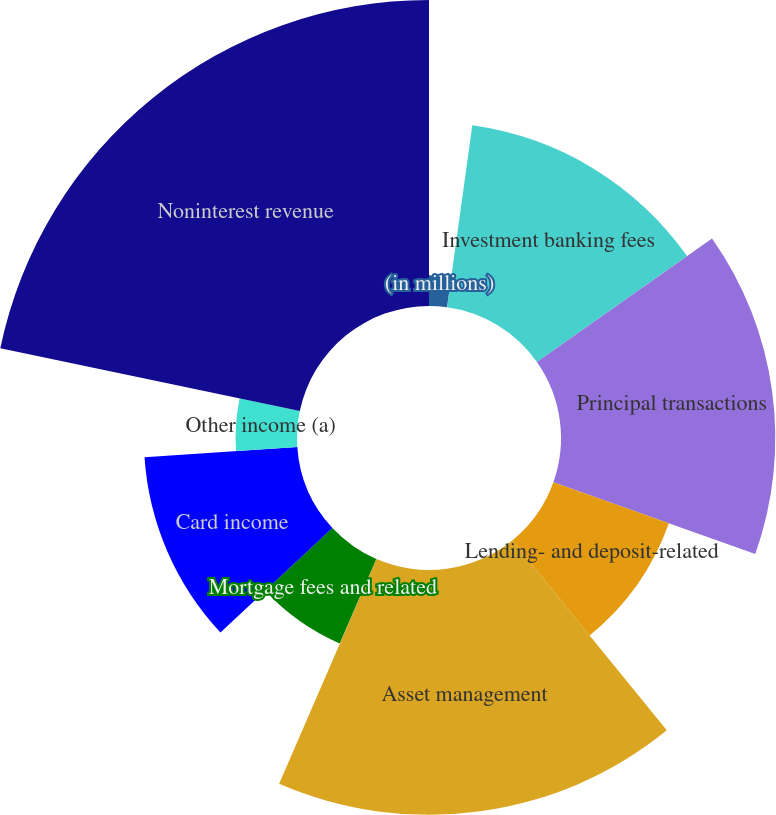<chart> <loc_0><loc_0><loc_500><loc_500><pie_chart><fcel>(in millions)<fcel>Investment banking fees<fcel>Principal transactions<fcel>Lending- and deposit-related<fcel>Asset management<fcel>Securities gains<fcel>Mortgage fees and related<fcel>Card income<fcel>Other income (a)<fcel>Noninterest revenue<nl><fcel>2.19%<fcel>13.04%<fcel>15.21%<fcel>8.7%<fcel>17.38%<fcel>0.02%<fcel>6.53%<fcel>10.87%<fcel>4.36%<fcel>21.72%<nl></chart> 